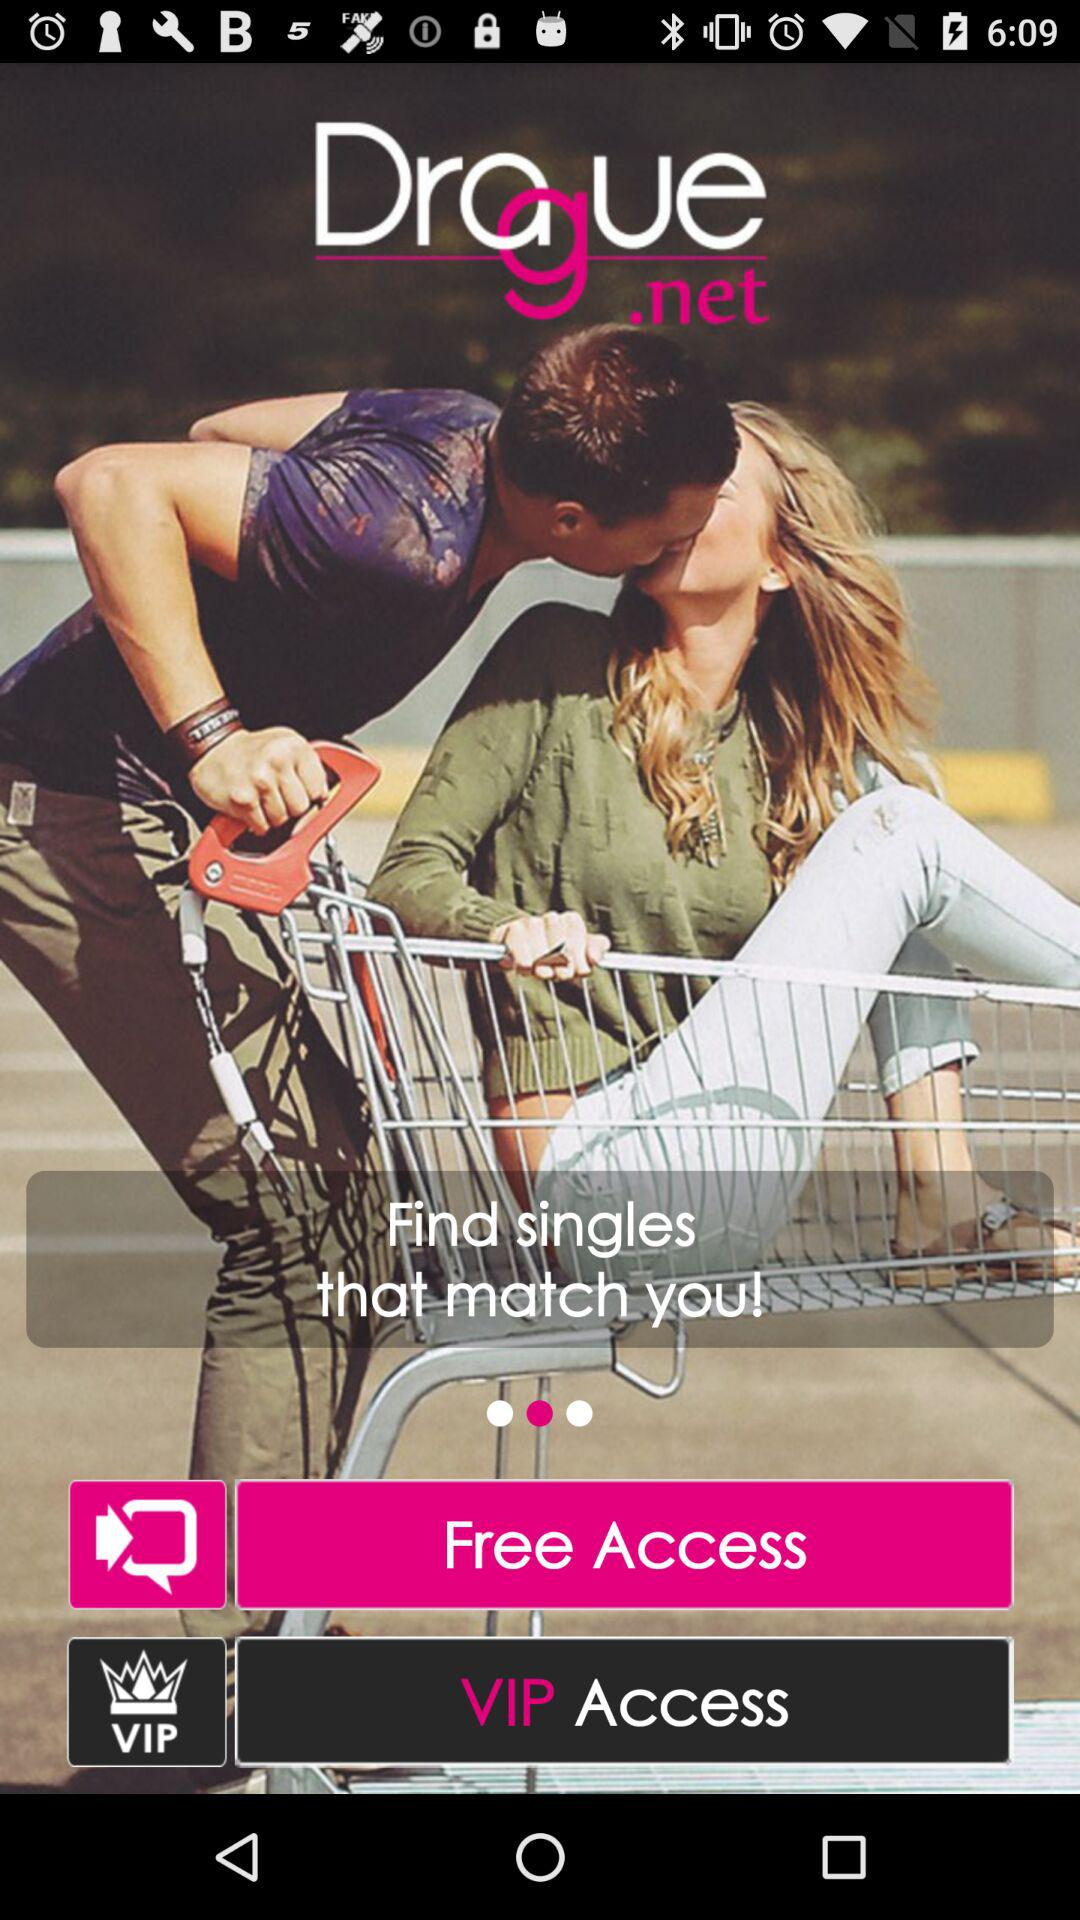What is the name of the application? The name of the application is "Drague.net". 